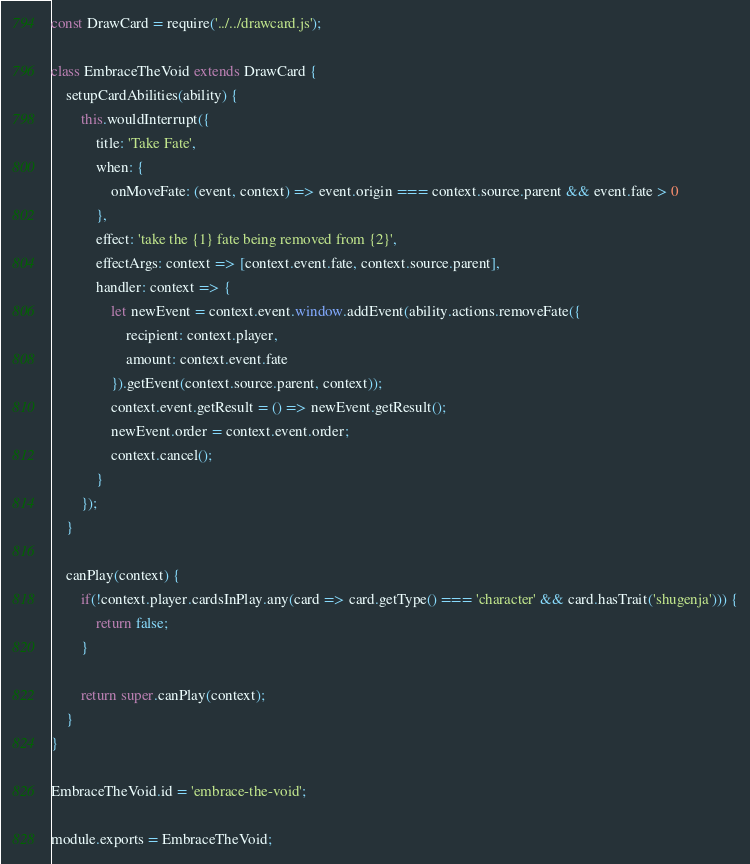<code> <loc_0><loc_0><loc_500><loc_500><_JavaScript_>const DrawCard = require('../../drawcard.js');

class EmbraceTheVoid extends DrawCard {
    setupCardAbilities(ability) {
        this.wouldInterrupt({
            title: 'Take Fate',
            when: {
                onMoveFate: (event, context) => event.origin === context.source.parent && event.fate > 0
            },
            effect: 'take the {1} fate being removed from {2}',
            effectArgs: context => [context.event.fate, context.source.parent],
            handler: context => {
                let newEvent = context.event.window.addEvent(ability.actions.removeFate({
                    recipient: context.player,
                    amount: context.event.fate
                }).getEvent(context.source.parent, context));
                context.event.getResult = () => newEvent.getResult();
                newEvent.order = context.event.order;
                context.cancel();
            }
        });
    }

    canPlay(context) {
        if(!context.player.cardsInPlay.any(card => card.getType() === 'character' && card.hasTrait('shugenja'))) {
            return false;
        }

        return super.canPlay(context);
    }
}

EmbraceTheVoid.id = 'embrace-the-void';

module.exports = EmbraceTheVoid;
</code> 